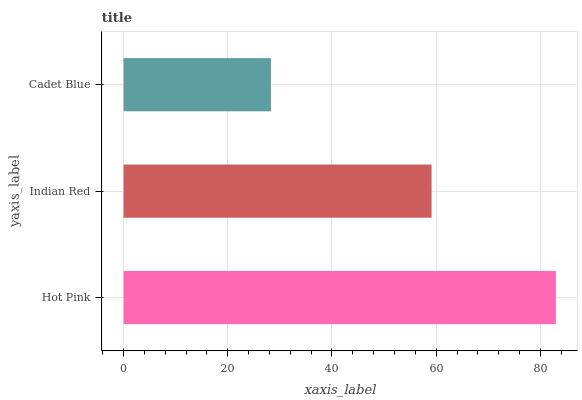Is Cadet Blue the minimum?
Answer yes or no. Yes. Is Hot Pink the maximum?
Answer yes or no. Yes. Is Indian Red the minimum?
Answer yes or no. No. Is Indian Red the maximum?
Answer yes or no. No. Is Hot Pink greater than Indian Red?
Answer yes or no. Yes. Is Indian Red less than Hot Pink?
Answer yes or no. Yes. Is Indian Red greater than Hot Pink?
Answer yes or no. No. Is Hot Pink less than Indian Red?
Answer yes or no. No. Is Indian Red the high median?
Answer yes or no. Yes. Is Indian Red the low median?
Answer yes or no. Yes. Is Hot Pink the high median?
Answer yes or no. No. Is Cadet Blue the low median?
Answer yes or no. No. 